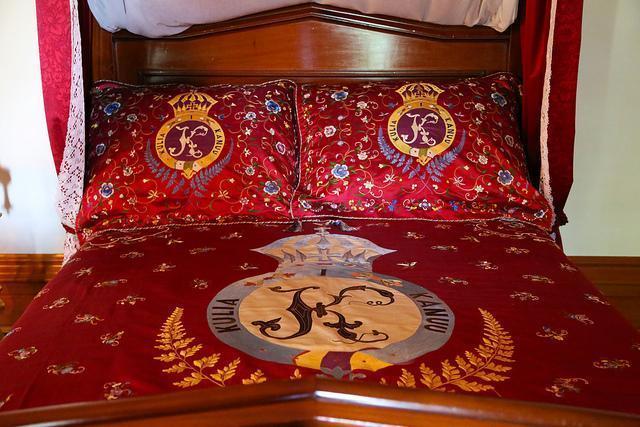How many pillows are there?
Give a very brief answer. 2. 